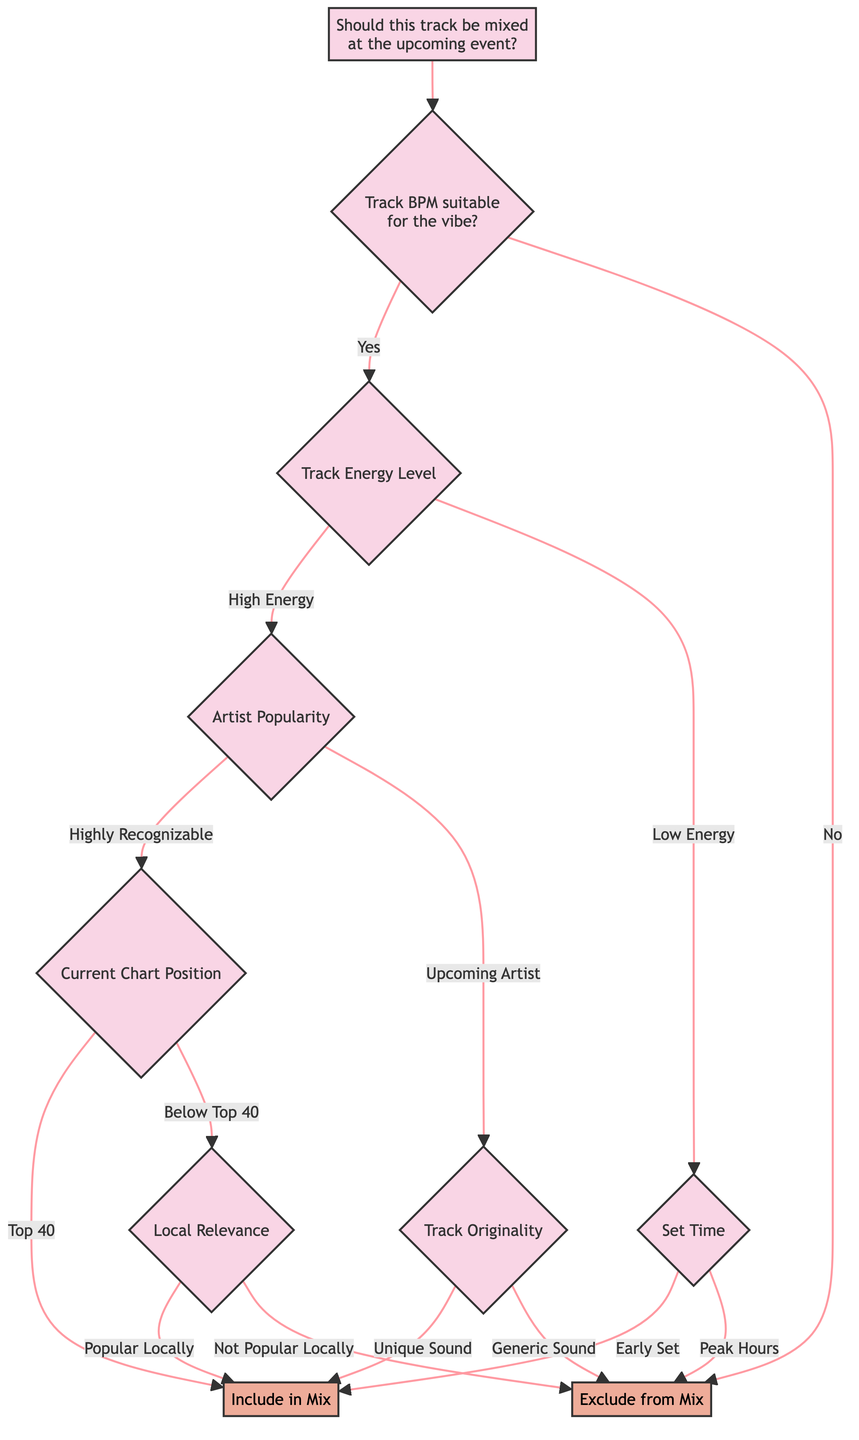What is the first question asked in the diagram? The first question asked in the diagram is "Should this track be mixed at the upcoming event?" This is the starting point of the decision process.
Answer: Should this track be mixed at the upcoming event? If the Track BPM is not suitable, what is the result? If the Track BPM is determined to be unsuitable for the vibe based on the second question, the flow leads directly to the result "Exclude from Mix." This indicates that any track with a BPM not matching the vibe is not included.
Answer: Exclude from Mix What happens if a track has high energy and is from a highly recognizable artist? If the track has high energy and comes from a highly recognizable artist, the diagram then asks about the track's current chart position. If it is in the top 40, the decision is to "Include in Mix," making it a strong candidate for mixing.
Answer: Include in Mix How many decisions are taken after confirming the BPM is suitable and the track has low energy? After confirming that the BPM is suitable and the track has low energy, the next question required to make a decision is regarding the set time. There are only one decision taken subsequently, leading to either "Include in Mix" or "Exclude from Mix."
Answer: One What does the decision tree suggest if the track has a generic sound? If the track has a generic sound, following the pathway for an upcoming artist, the decision is to "Exclude from Mix." This indicates that tracks lacking originality are not suitable for inclusion in the mix.
Answer: Exclude from Mix In which scenario does the diagram recommend including a track in the mix based on local relevance? The diagram recommends including a track in the mix based on local relevance when its current chart position is below top 40, and the track is popular locally. This suggests local popularity can help decide the inclusion even if the track is not charting high nationally.
Answer: Include in Mix What is the criterion for including a track with low energy during peak hours? The criterion for including a track with low energy is that it must be during an early set time. If the set is during peak hours, the decision shifts to "Exclude from Mix." Thus, low energy tracks are reserved for certain times.
Answer: Exclude from Mix 